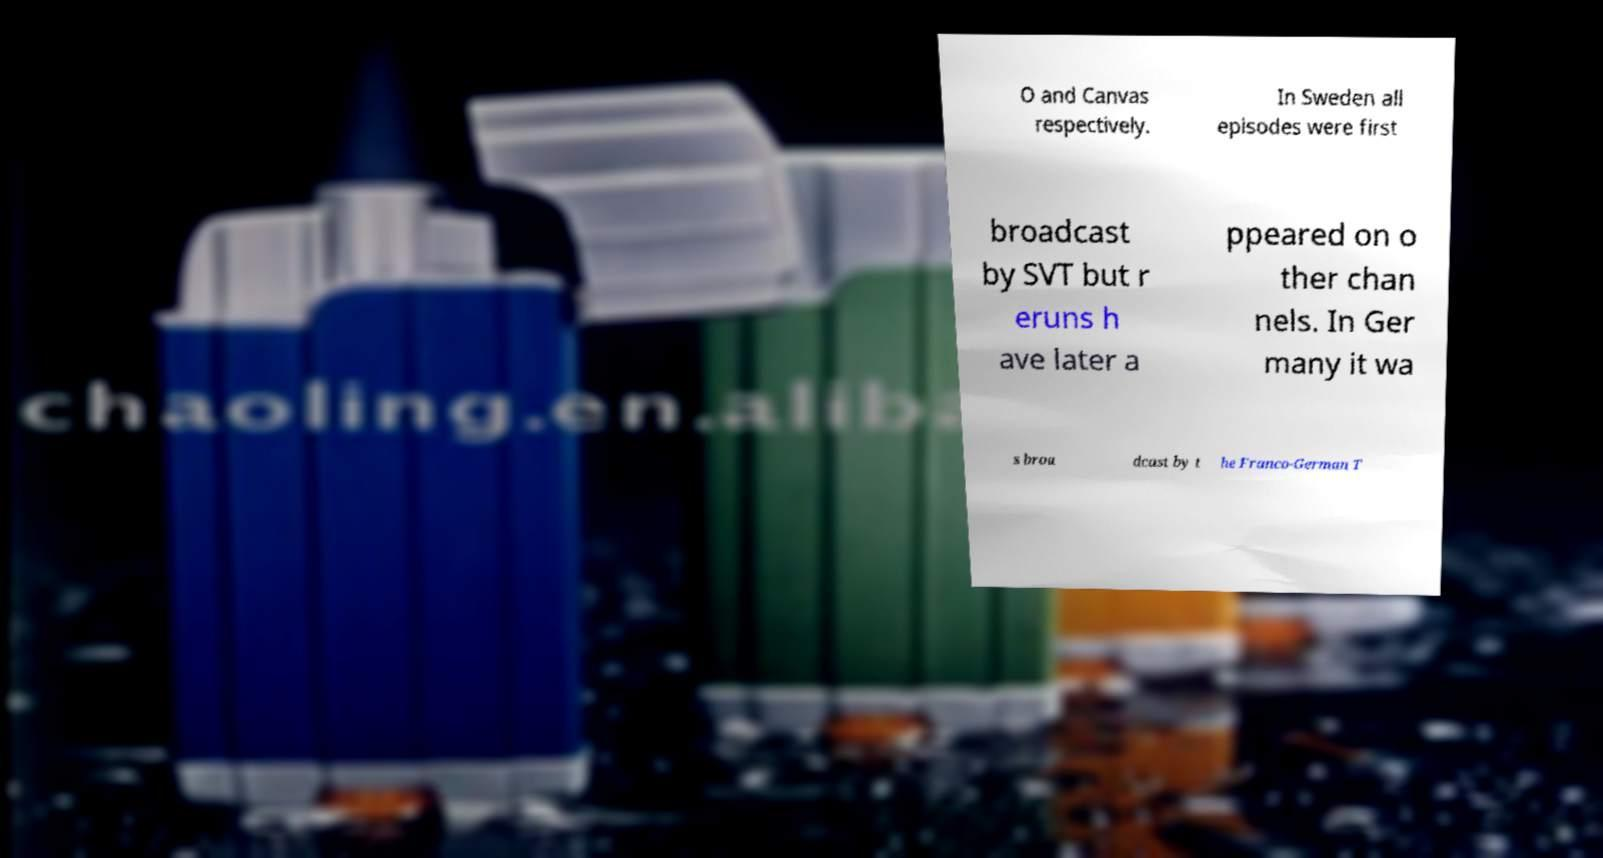What messages or text are displayed in this image? I need them in a readable, typed format. O and Canvas respectively. In Sweden all episodes were first broadcast by SVT but r eruns h ave later a ppeared on o ther chan nels. In Ger many it wa s broa dcast by t he Franco-German T 